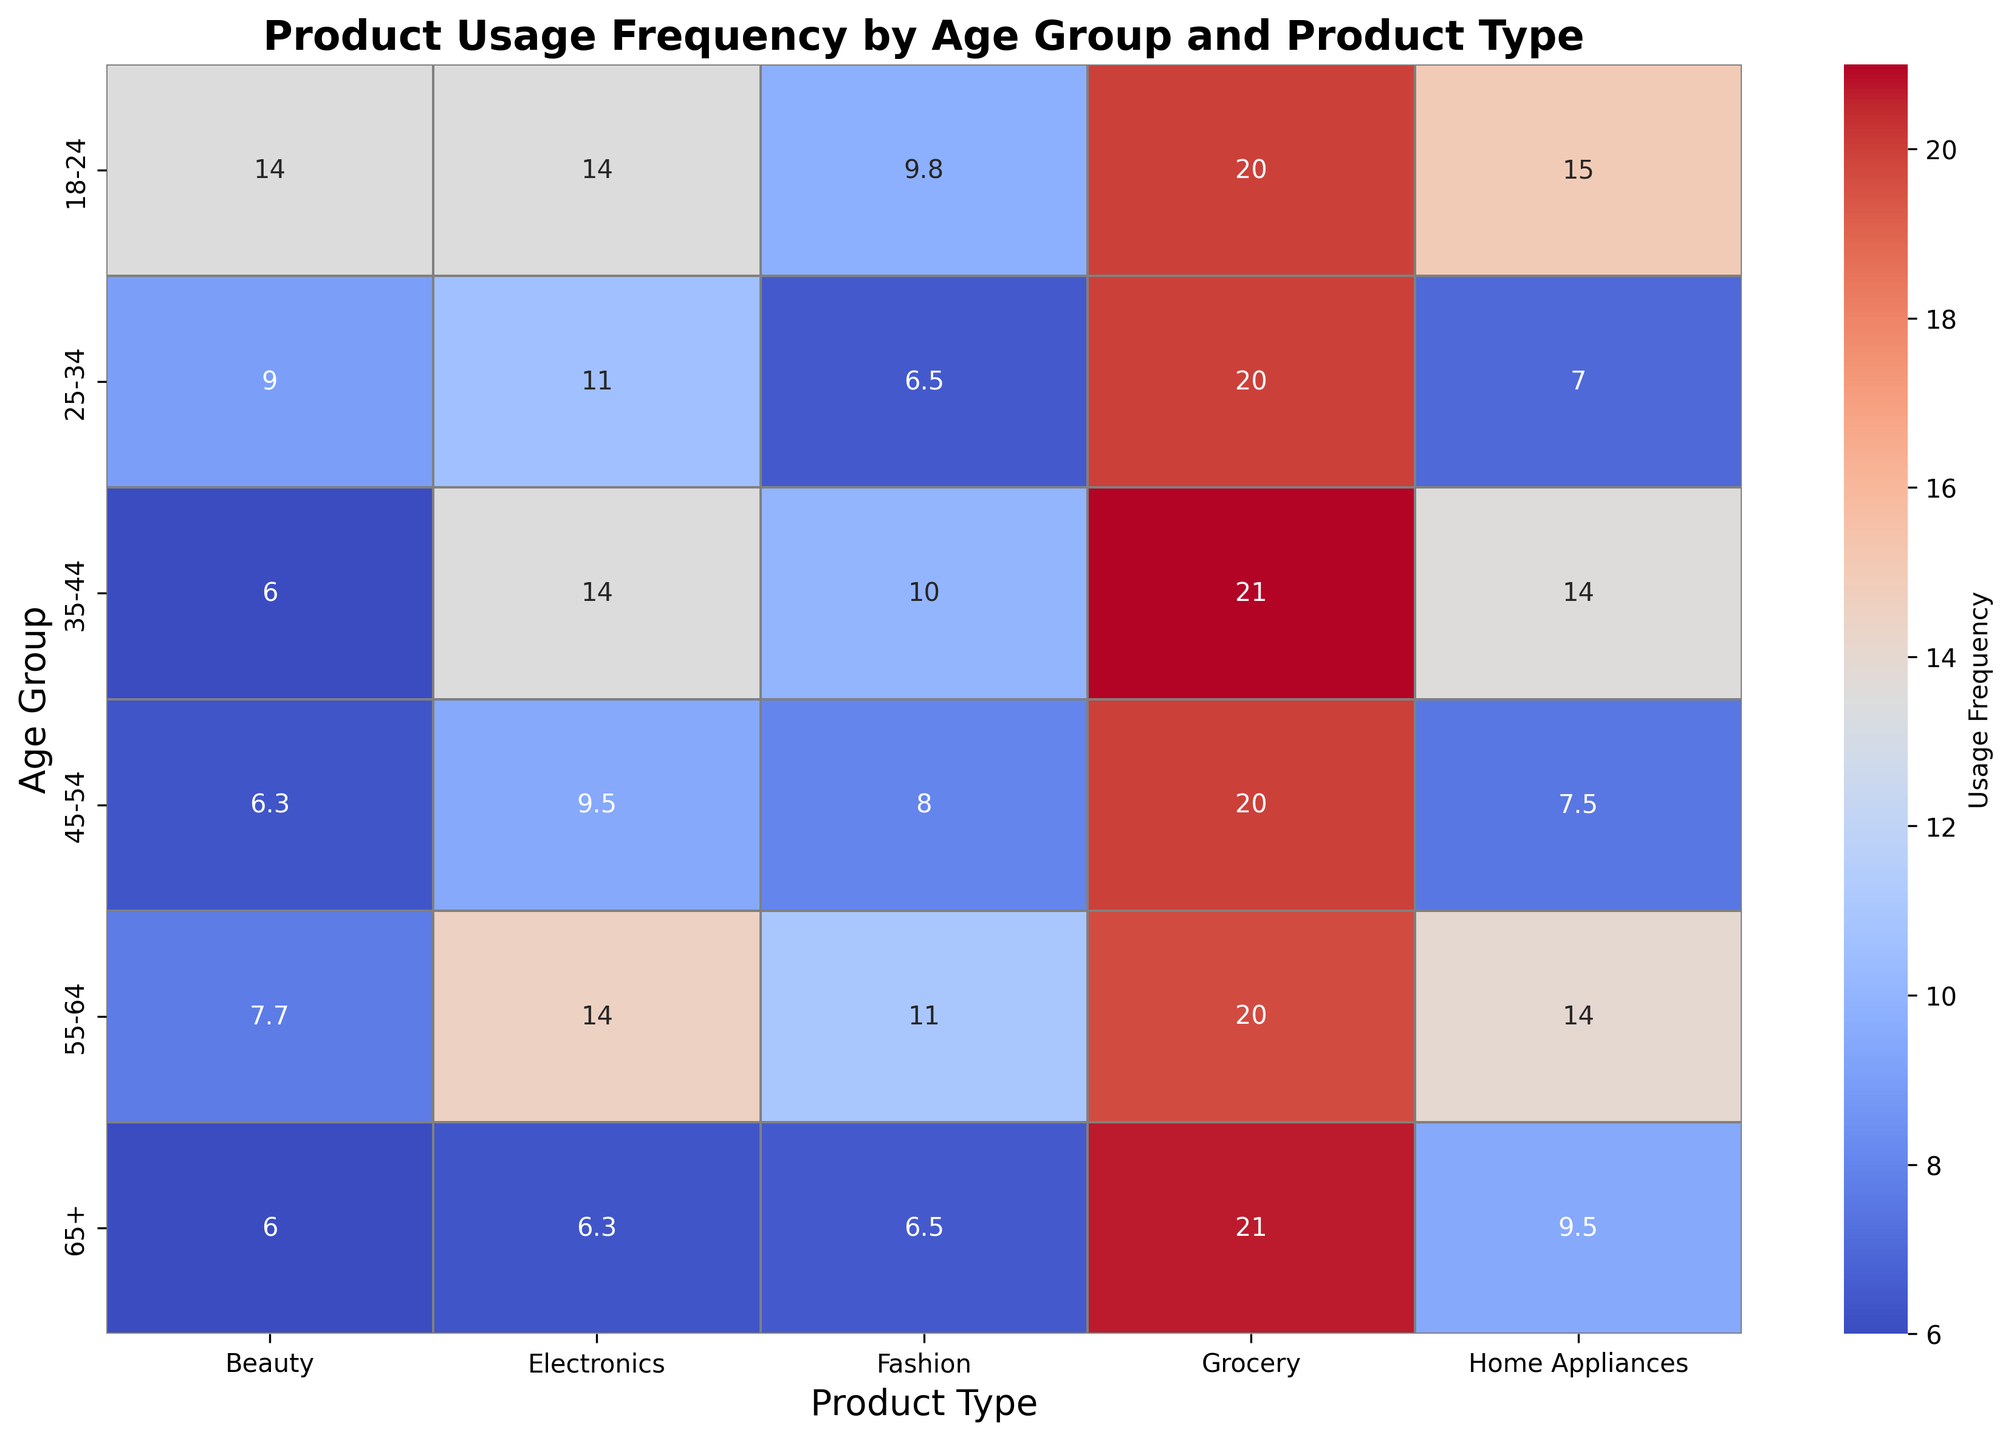What age group shows the highest average usage frequency for the product type "Grocery"? First, locate the column corresponding to "Grocery". Then, find the row with the highest value in that column which represents the highest average usage frequency.
Answer: 35-44 Which product type has the highest usage frequency in the 18-24 age group? Locate the row for the 18-24 age group. Identify the column with the highest value in that row, indicating the highest usage frequency.
Answer: Grocery Compare the average usage frequency of "Electronics" between the age groups 25-34 and 65+. Which group uses this product type more frequently? Locate the "Electronics" column and compare the values in the rows for age groups 25-34 and 65+. The higher value indicates more frequent usage.
Answer: 25-34 What is the difference in usage frequency between "Home Appliances" for the 35-44 age group and the 55-64 age group? Locate the "Home Appliances" column, identify the values for age groups 35-44 and 55-64, and calculate their difference.
Answer: 1 Calculate the average usage frequency for "Beauty" products across all age groups. Sum the values in the "Beauty" column (18+10+8+12+8+11) and divide by the number of age groups (6).
Answer: 11.15 Which age group has the least variation in usage frequencies across all product types? Compare the range (difference between max and min values) of usage frequencies across all product types for each age group. The group with the smallest range has the least variation.
Answer: 65+ Identify the product type and age group combination with the lowest average usage frequency. Scan through the table to identify the cell with the lowest value, and note its corresponding product type and age group.
Answer: Beauty, 65+ Is "Fashion" more popular among younger age groups (18-24, 25-34) or older age groups (55-64, 65+)? Compare the average usage frequencies. Calculate the average usage frequency for "Fashion" for younger age groups and compare it with the average for older age groups.
Answer: Younger age groups What is the combined usage frequency for "Home Appliances" for the 25-34 and 45-54 age groups? Locate the "Home Appliances" column, sum the values for age groups 25-34 and 45-54.
Answer: 8 Which product type has the greatest difference in usage frequency between the 18-24 and 65+ age groups? For each product type, calculate the difference in usage frequency between the 18-24 and 65+ age groups. Identify the product type with the largest difference.
Answer: Home Appliances 